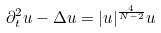Convert formula to latex. <formula><loc_0><loc_0><loc_500><loc_500>\partial _ { t } ^ { 2 } u - \Delta u = | u | ^ { \frac { 4 } { N - 2 } } u</formula> 